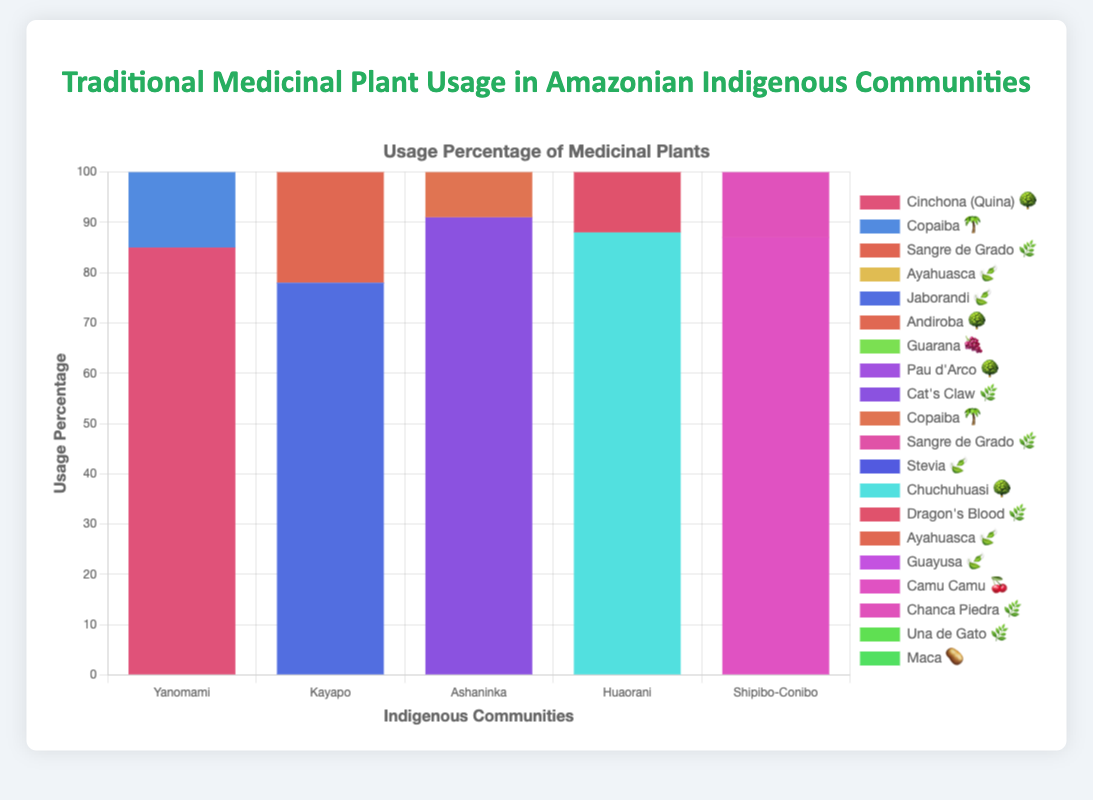What is the title of the chart? The title is usually the largest text at the top and provides an overview of what the chart represents.
Answer: Traditional Medicinal Plant Usage in Amazonian Indigenous Communities Which community uses Ayahuasca 🍃 the most? Look at the dataset under each community's information and check the usage percentage for Ayahuasca 🍃. The highest usage percentage indicates the most usage.
Answer: Yanomami How many medicinal plants are visually represented for the Huaorani community? Each distinct bar or plant emoji next to the Huaorani label represents a different medicinal plant used by the community. Count these distinct items.
Answer: 4 What is the total usage percentage of medicinal plants for the Kayapo community? Sum the usage percentages of all medicinal plants listed under the Kayapo community in the dataset.
Answer: 324 How does the usage of Copaiba 🌴 compare between Yanomami and Ashaninka communities? Compare the usage percentages of Copaiba 🌴 from both communities by referring to the respective bars.
Answer: Yanomami: 72, Ashaninka: 76; Ashaninka uses more Which medicinal plant is used most by the Shipibo-Conibo community? Identify the highest number among the usage percentages in the Shipibo-Conibo category.
Answer: Una de Gato 🌿 Which two communities use Ayahuasca 🍃, and what are their respective usage percentages? Identify the communities that have Ayahuasca 🍃 listed in their plants and note the associated usage percentages.
Answer: Yanomami: 95, Huaorani: 93 What is the average usage percentage of Sangre de Grado 🌿 across all communities that use it? Note the usage percentages of Sangre de Grado 🌿 in all communities and calculate the average. (Yanomami: 68, Ashaninka: 82) The average is (68 + 82) / 2 = 75.
Answer: 75 Which community uses the most number of different medicinal plants? Count the number of unique plants listed for each community and identify the one with the highest count.
Answer: Huaorani What is the combined usage percentage of Jaborandi 🍃 and Guarana 🍇 in the Kayapo community? Sum the usage percentages for Jaborandi 🍃 and Guarana 🍇 in the Kayapo community.
Answer: 170 